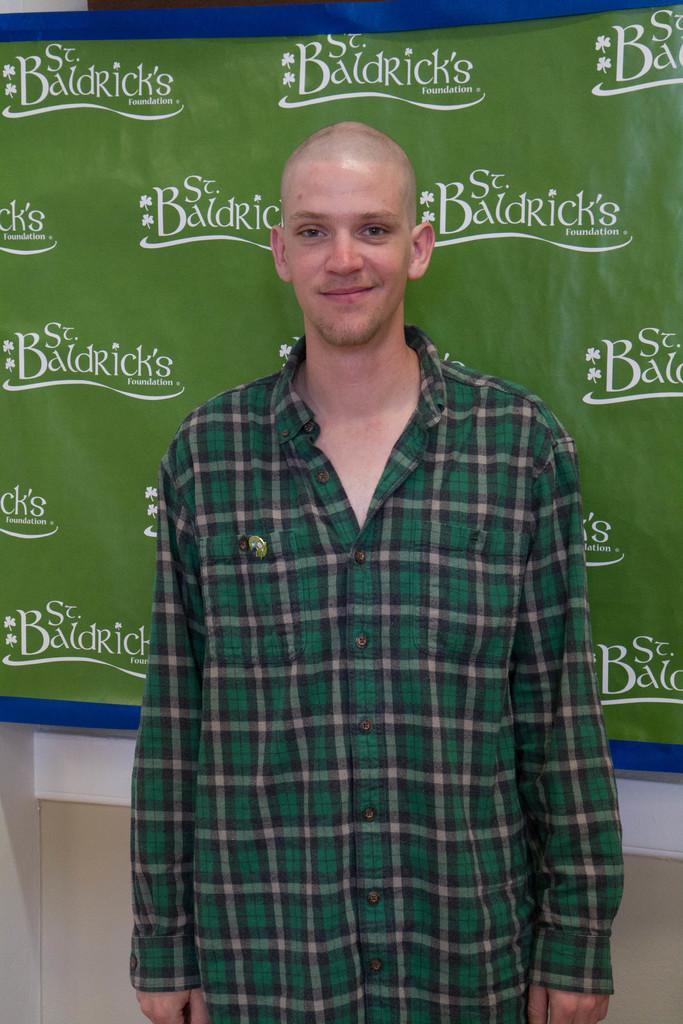Please provide a concise description of this image. In this image we can see a man and he is smiling. In the background we can see a banner and wall. On the banner we can see something is written on it. 